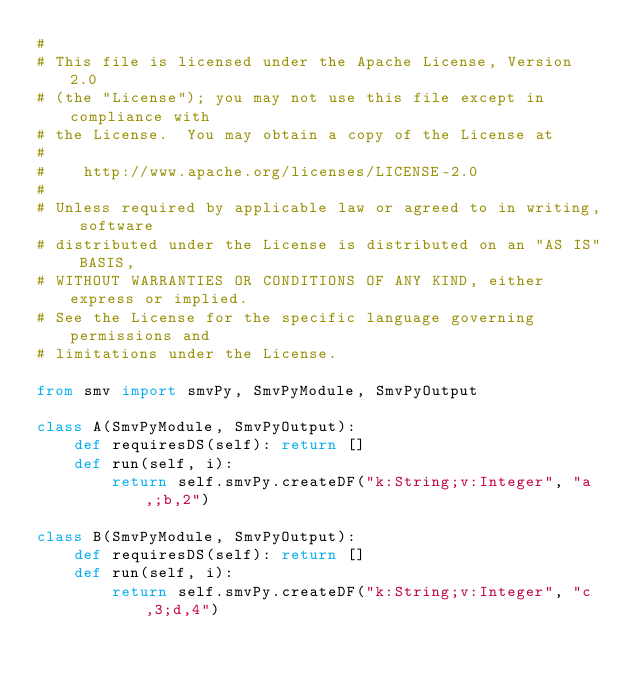<code> <loc_0><loc_0><loc_500><loc_500><_Python_>#
# This file is licensed under the Apache License, Version 2.0
# (the "License"); you may not use this file except in compliance with
# the License.  You may obtain a copy of the License at
#
#    http://www.apache.org/licenses/LICENSE-2.0
#
# Unless required by applicable law or agreed to in writing, software
# distributed under the License is distributed on an "AS IS" BASIS,
# WITHOUT WARRANTIES OR CONDITIONS OF ANY KIND, either express or implied.
# See the License for the specific language governing permissions and
# limitations under the License.

from smv import smvPy, SmvPyModule, SmvPyOutput

class A(SmvPyModule, SmvPyOutput):
    def requiresDS(self): return []
    def run(self, i):
        return self.smvPy.createDF("k:String;v:Integer", "a,;b,2")

class B(SmvPyModule, SmvPyOutput):
    def requiresDS(self): return []
    def run(self, i):
        return self.smvPy.createDF("k:String;v:Integer", "c,3;d,4")
</code> 